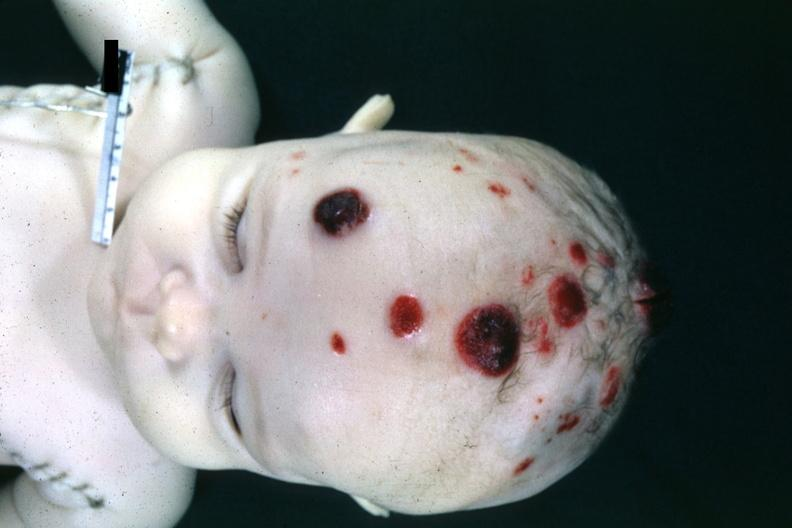what are appearing skin nodules infiltrates 4 month old child several slides from this case are in this file?
Answer the question using a single word or phrase. Lymphoma 